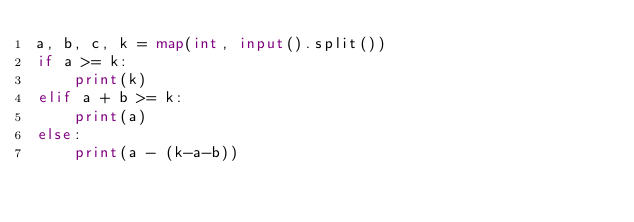<code> <loc_0><loc_0><loc_500><loc_500><_Python_>a, b, c, k = map(int, input().split())
if a >= k:
    print(k)
elif a + b >= k:
    print(a)
else:
    print(a - (k-a-b))
</code> 